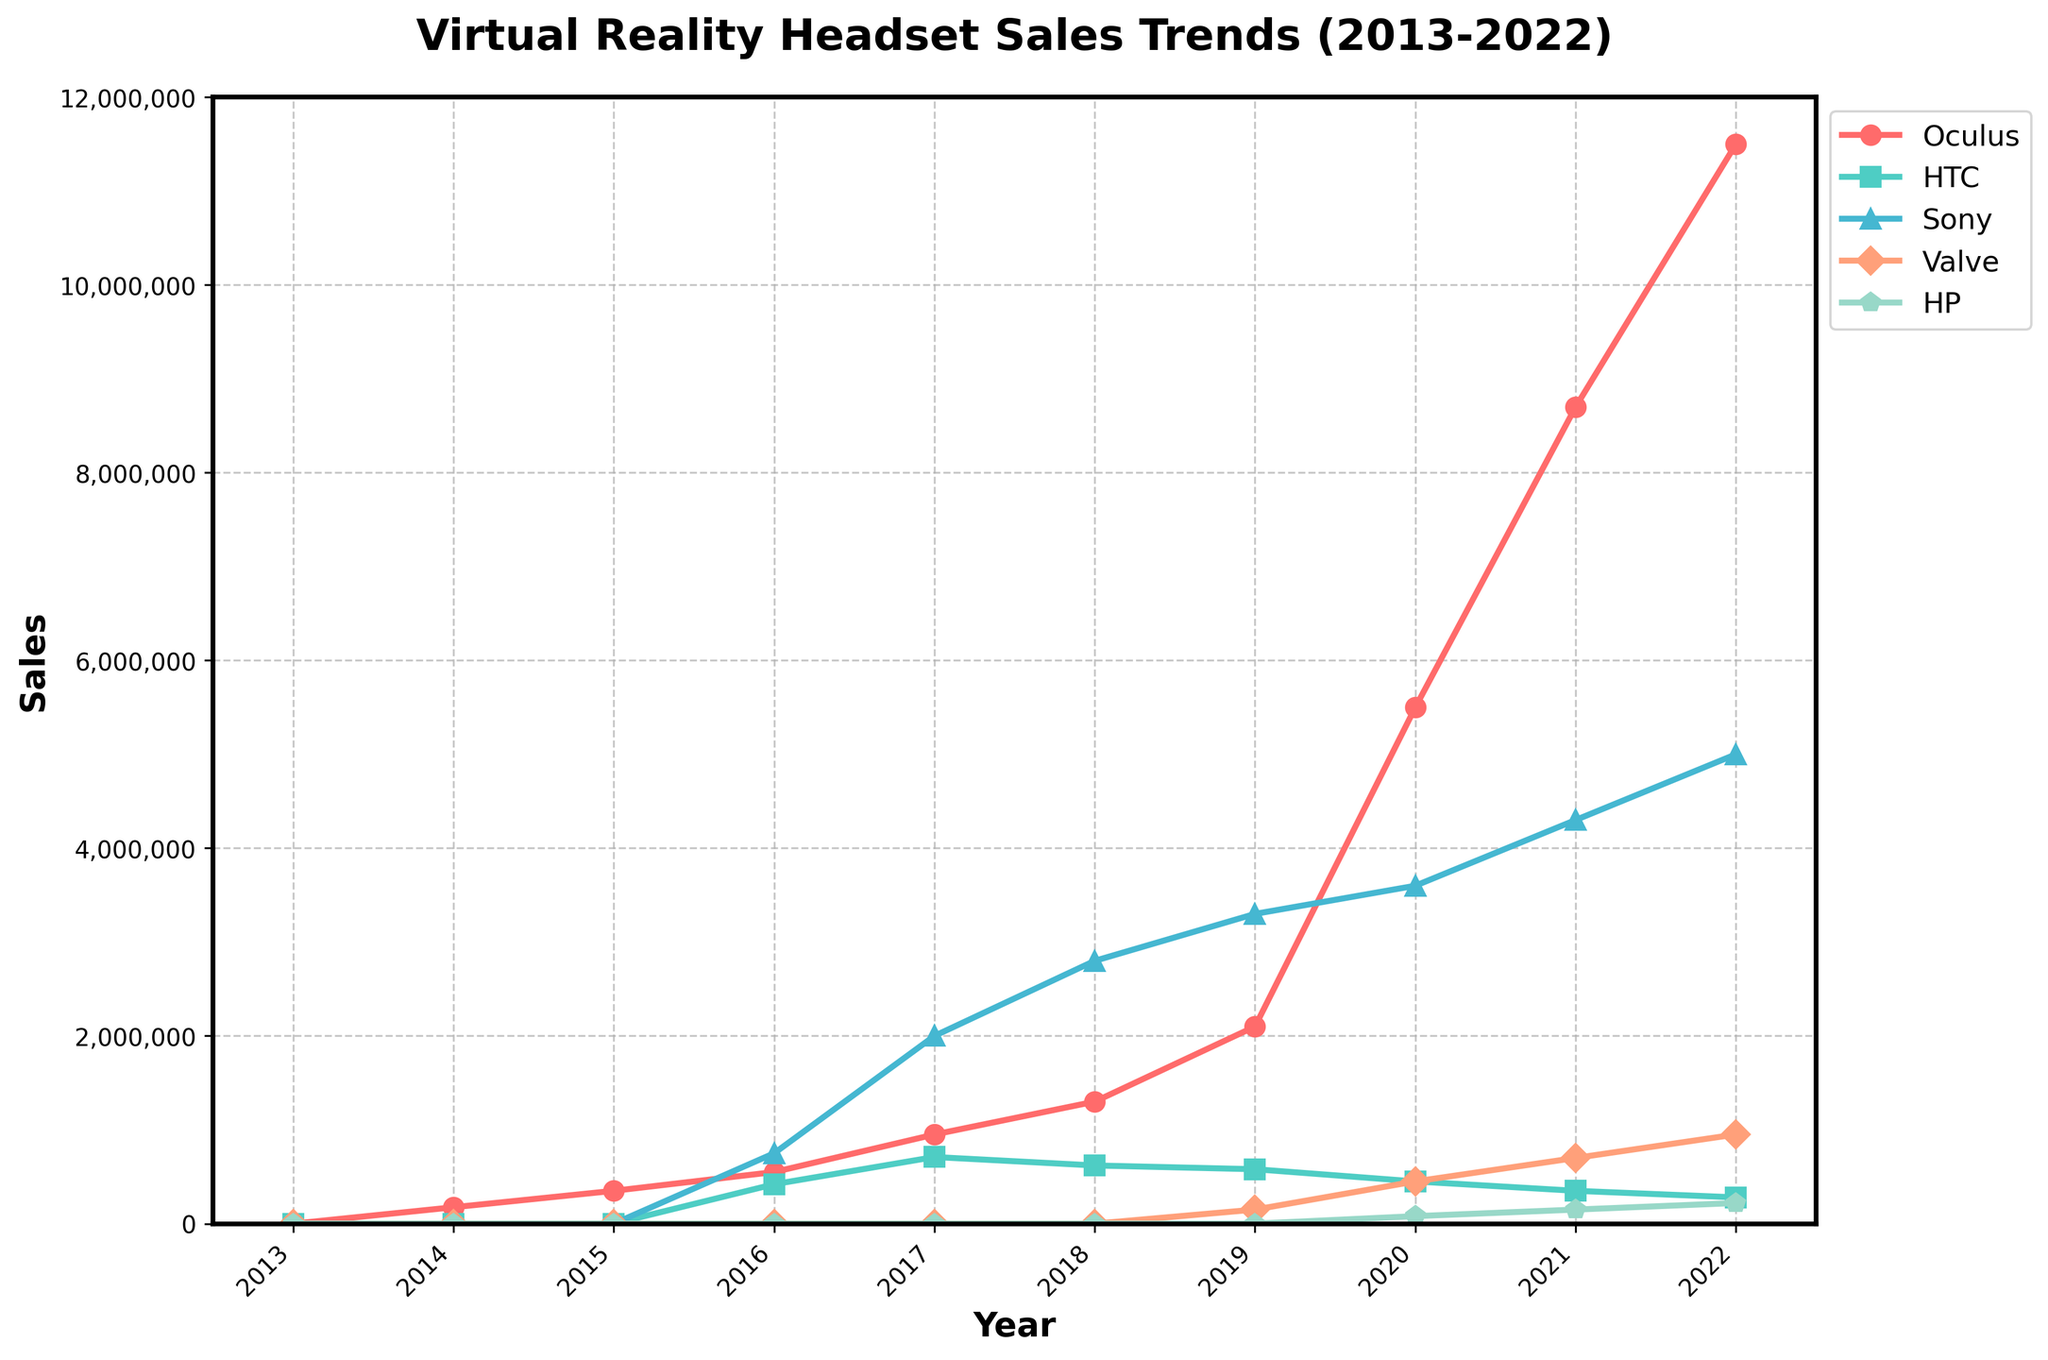What year did Oculus sales exceed 1 million units? As per the figure, Oculus sales surpassed 1 million units in 2018. To find this, look at the trend line for Oculus and identify the year when it first goes above the 1 million mark.
Answer: 2018 Which manufacturer had the highest sales in 2022? By inspecting the height of the lines in 2022, Sony had the highest sales with 5,000,000 units. Look at the labels on the y-axis to determine the highest value reached by any line.
Answer: Sony What is the total sales for HTC across all the years displayed? Summing the sales figures for HTC across all years: 0 (2013) + 0 (2014) + 0 (2015) + 420,000 (2016) + 710,000 (2017) + 620,000 (2018) + 580,000 (2019) + 450,000 (2020) + 350,000 (2021) + 280,000 (2022) = 3,410,000.
Answer: 3,410,000 Which year saw the largest increase in Oculus sales compared to the previous year? Calculate the annual difference in Oculus sales and find the year with the largest increase. Significant increases are from 2019 to 2020 (5,500,000 - 2,100,000 = 3,400,000).
Answer: 2020 How did Valve's sales change from 2019 to 2022? Valve had 150,000 units sold in 2019 and 950,000 in 2022. The change is calculated as 950,000 - 150,000 which is an increase of 800,000 units.
Answer: 800,000 increase Who had lower sales in 2021: HTC or HP? Look at the sales figures for both HTC (350,000 units) and HP (150,000 units) in 2021, confirming that HP had lower sales.
Answer: HP What was the combined sales of Oculus and Sony in 2016? The combined sales for 2016 are Oculus (550,000) + Sony (750,000) = 1,300,000.
Answer: 1,300,000 Based on the overall trend, which VR manufacturer shows the most consistent yearly growth? Oculus demonstrates the most consistent growth with increasing sales every year from 2014 to 2022. Observing the smooth upward sloping line confirms this.
Answer: Oculus How many years did it take for Oculus sales to reach 8,700,000 units from 350,000 units? Oculus had 350,000 units in 2015 and 8,700,000 units in 2021. Finding the difference (2021 - 2015) reveals it took 6 years.
Answer: 6 years Between Sony and HP, whose sales saw a noticeable fluctuation in the later years (2019-2022)? Comparing the trends, Sony's sales gradually increased while HP's sales fluctuated from 0 in 2019 to 150,000 in 2021, noticeable fluctuations occur in HP's line.
Answer: HP 